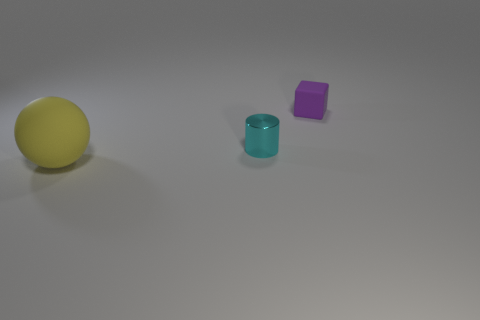Does the small object that is to the left of the small cube have the same material as the yellow ball? No, the small object to the left of the purple cube, which appears to be a small cyan cylinder, does not seem to have the same material as the yellow ball. The yellow ball has a matte surface indicative of a rubber or plastic material, while the cylinder has a more reflective surface that suggests it's made of a glossy material like polished metal or glazed ceramic. 